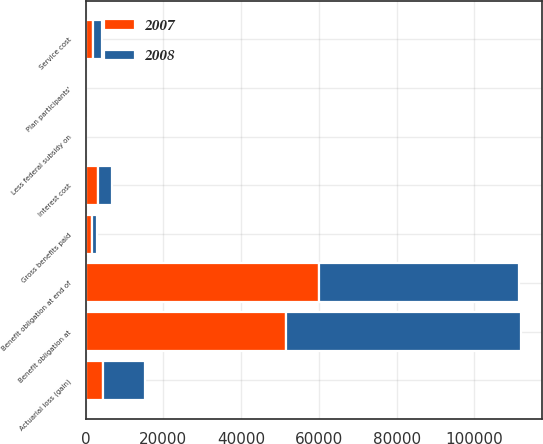Convert chart to OTSL. <chart><loc_0><loc_0><loc_500><loc_500><stacked_bar_chart><ecel><fcel>Benefit obligation at<fcel>Service cost<fcel>Interest cost<fcel>Plan participants'<fcel>Actuarial loss (gain)<fcel>Gross benefits paid<fcel>Less federal subsidy on<fcel>Benefit obligation at end of<nl><fcel>2007<fcel>51598<fcel>1951<fcel>3288<fcel>74<fcel>4564<fcel>1582<fcel>56<fcel>59949<nl><fcel>2008<fcel>60346<fcel>2354<fcel>3392<fcel>73<fcel>10663<fcel>1282<fcel>71<fcel>51598<nl></chart> 